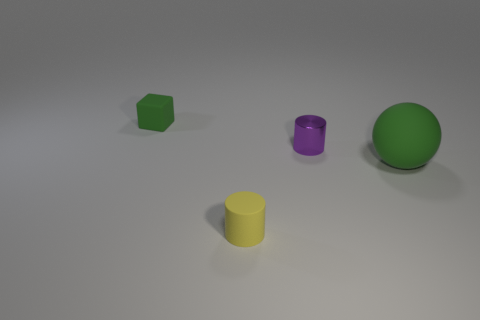Add 2 purple metallic cylinders. How many objects exist? 6 Subtract all blocks. How many objects are left? 3 Subtract all yellow cylinders. Subtract all small green matte spheres. How many objects are left? 3 Add 4 rubber cubes. How many rubber cubes are left? 5 Add 1 yellow metallic spheres. How many yellow metallic spheres exist? 1 Subtract 0 purple balls. How many objects are left? 4 